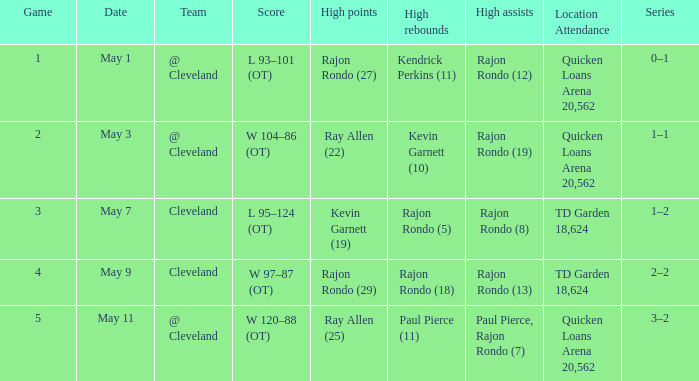Where does the team play May 3? @ Cleveland. 